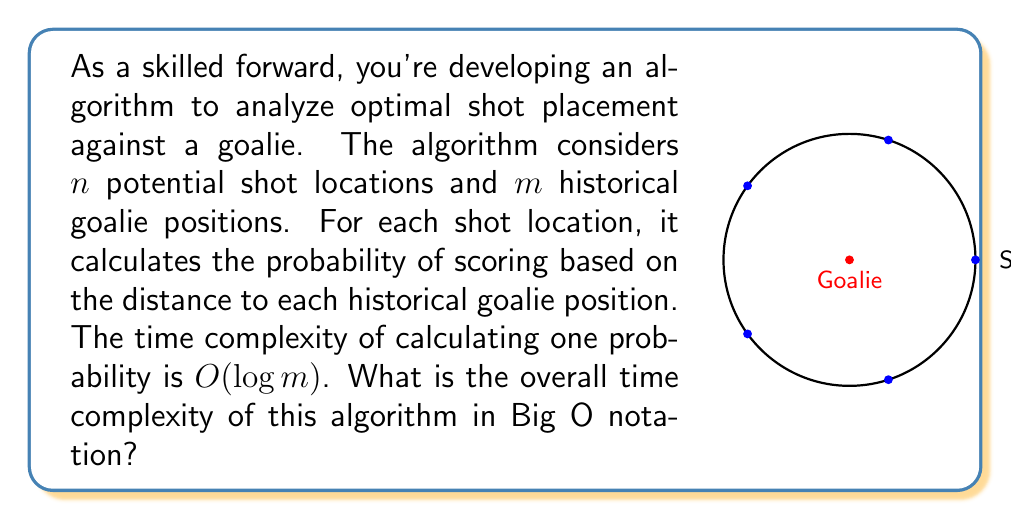Could you help me with this problem? Let's break down the algorithm and analyze its time complexity step by step:

1) We have $n$ potential shot locations.

2) For each shot location, we need to consider $m$ historical goalie positions.

3) For each pair of shot location and goalie position, we calculate the probability of scoring. This calculation has a time complexity of $O(\log m)$.

4) Therefore, for a single shot location, we perform $m$ calculations, each taking $O(\log m)$ time. The time complexity for one shot location is:

   $O(m \cdot \log m)$

5) We repeat this process for all $n$ shot locations. So, we multiply the time complexity by $n$:

   $O(n \cdot m \cdot \log m)$

6) This is our final time complexity. We can't simplify it further because $n$ and $m$ are independent variables.

The overall time complexity of the algorithm is $O(n \cdot m \cdot \log m)$.
Answer: $O(n \cdot m \cdot \log m)$ 